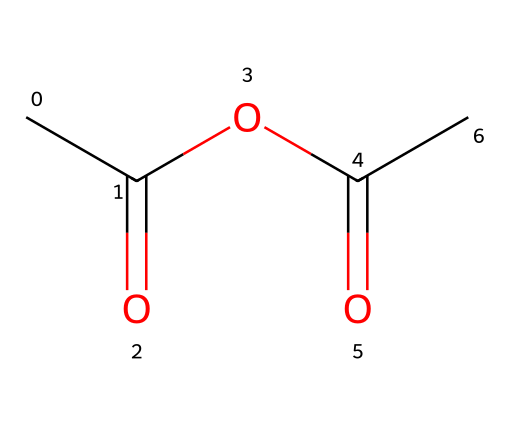What is the molecular formula of acetic anhydride? By analyzing the SMILES representation CC(=O)OC(=O)C, we can deduce the molecular formula by counting the atoms: there are 4 carbon (C) atoms, 6 hydrogen (H) atoms, and 3 oxygen (O) atoms. Thus, the molecular formula is C4H6O3.
Answer: C4H6O3 How many carbon atoms are present in acetic anhydride? Looking at the SMILES notation, the string CC(=O)OC(=O)C indicates that there are four occurrences of the carbon atom represented, which indicates the presence of four carbon atoms in total.
Answer: 4 What type of functional groups are present in acetic anhydride? The SMILES representation shows two groups of carbonyl (C=O) attached to ether linkage (R-O-R), indicating the presence of an anhydride functional group due to the characteristic structure with two acyl groups connected by an oxygen atom.
Answer: anhydride Is acetic anhydride a strong or weak acid anhydride? Acetic anhydride is considered a weak acid anhydride because it derives from a weak acid (acetic acid) and does not dissociate completely in solution, leading to its classification as a weak acid anhydride.
Answer: weak What is the significance of the acyl group in acetic anhydride? The acyl group (RCO-) in acetic anhydride plays a significant role in its reactivity, participating in acylation reactions and influencing its behavior in various chemical processes due to its electrophilic nature.
Answer: reactivity What is the boiling point range of acetic anhydride? The boiling point of acetic anhydride is typically around 139 to 140 degrees Celsius, which can be derived from its physical properties and established data regarding its boiling point range.
Answer: 139-140 degrees Celsius 